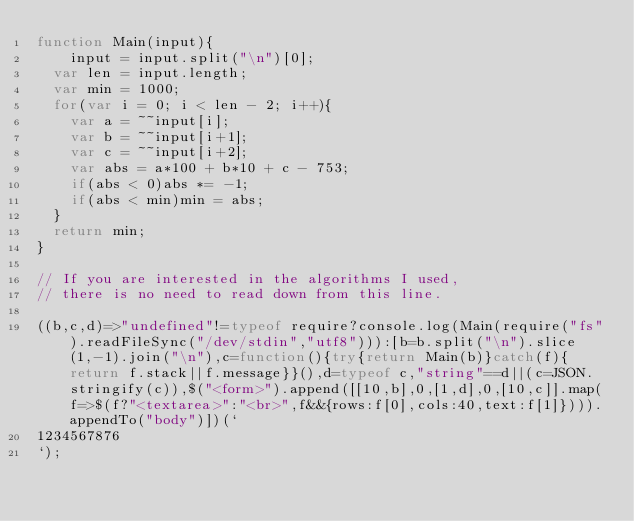<code> <loc_0><loc_0><loc_500><loc_500><_JavaScript_>function Main(input){
	input = input.split("\n")[0];
  var len = input.length;
  var min = 1000;
  for(var i = 0; i < len - 2; i++){
  	var a = ~~input[i];
    var b = ~~input[i+1];
    var c = ~~input[i+2];
    var abs = a*100 + b*10 + c - 753;
    if(abs < 0)abs *= -1;
    if(abs < min)min = abs;
  }
  return min;
}

// If you are interested in the algorithms I used, 
// there is no need to read down from this line.

((b,c,d)=>"undefined"!=typeof require?console.log(Main(require("fs").readFileSync("/dev/stdin","utf8"))):[b=b.split("\n").slice(1,-1).join("\n"),c=function(){try{return Main(b)}catch(f){return f.stack||f.message}}(),d=typeof c,"string"==d||(c=JSON.stringify(c)),$("<form>").append([[10,b],0,[1,d],0,[10,c]].map(f=>$(f?"<textarea>":"<br>",f&&{rows:f[0],cols:40,text:f[1]}))).appendTo("body")])(`
1234567876
`);</code> 